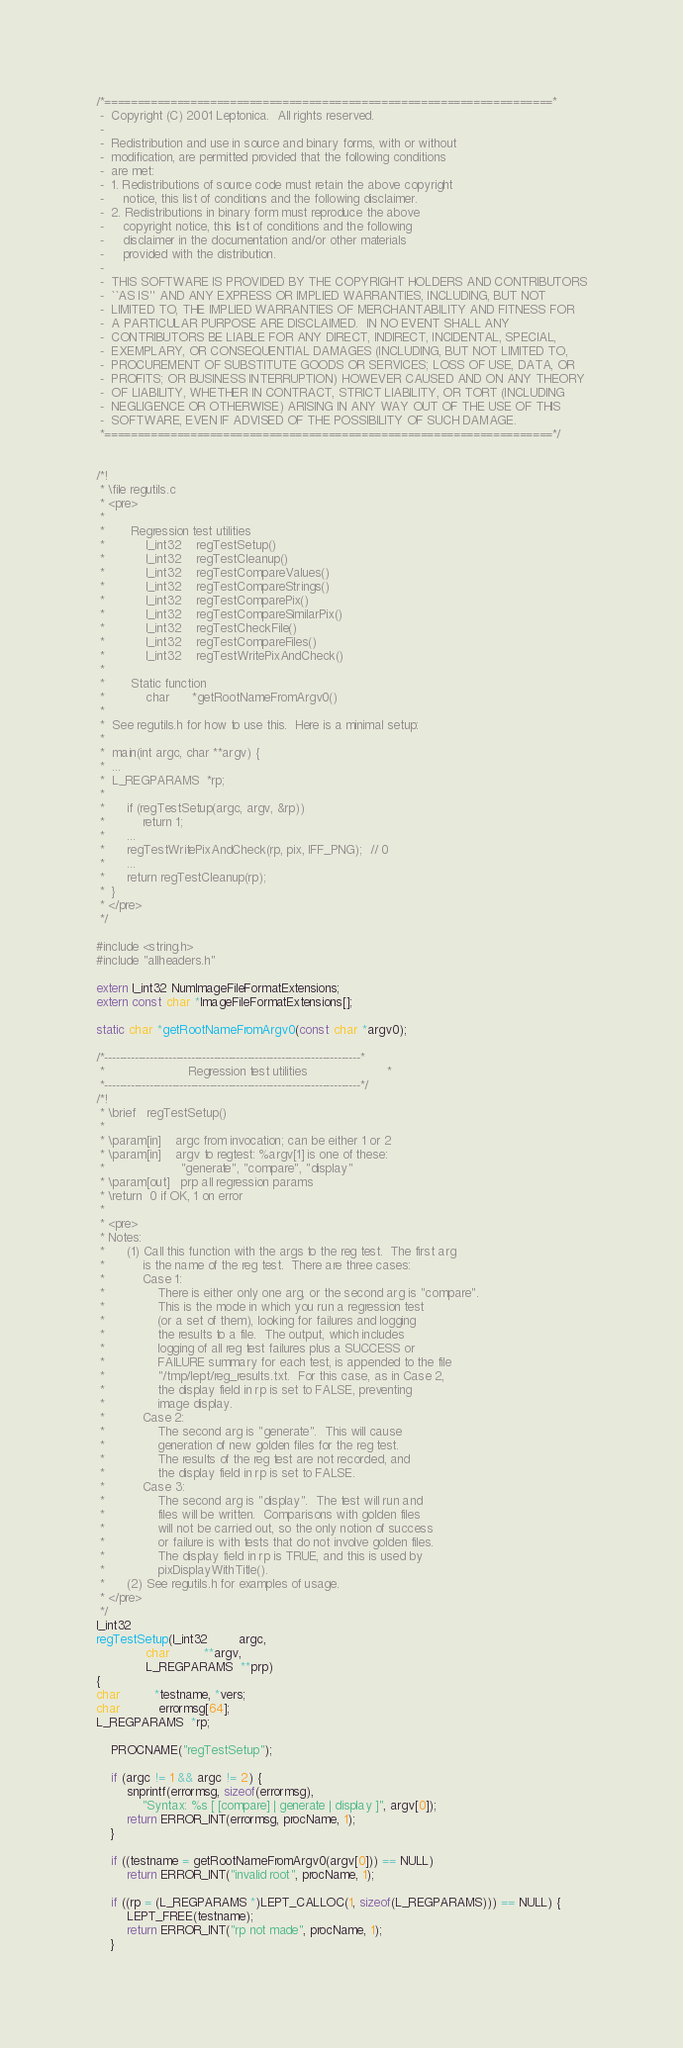<code> <loc_0><loc_0><loc_500><loc_500><_C_>/*====================================================================*
 -  Copyright (C) 2001 Leptonica.  All rights reserved.
 -
 -  Redistribution and use in source and binary forms, with or without
 -  modification, are permitted provided that the following conditions
 -  are met:
 -  1. Redistributions of source code must retain the above copyright
 -     notice, this list of conditions and the following disclaimer.
 -  2. Redistributions in binary form must reproduce the above
 -     copyright notice, this list of conditions and the following
 -     disclaimer in the documentation and/or other materials
 -     provided with the distribution.
 -
 -  THIS SOFTWARE IS PROVIDED BY THE COPYRIGHT HOLDERS AND CONTRIBUTORS
 -  ``AS IS'' AND ANY EXPRESS OR IMPLIED WARRANTIES, INCLUDING, BUT NOT
 -  LIMITED TO, THE IMPLIED WARRANTIES OF MERCHANTABILITY AND FITNESS FOR
 -  A PARTICULAR PURPOSE ARE DISCLAIMED.  IN NO EVENT SHALL ANY
 -  CONTRIBUTORS BE LIABLE FOR ANY DIRECT, INDIRECT, INCIDENTAL, SPECIAL,
 -  EXEMPLARY, OR CONSEQUENTIAL DAMAGES (INCLUDING, BUT NOT LIMITED TO,
 -  PROCUREMENT OF SUBSTITUTE GOODS OR SERVICES; LOSS OF USE, DATA, OR
 -  PROFITS; OR BUSINESS INTERRUPTION) HOWEVER CAUSED AND ON ANY THEORY
 -  OF LIABILITY, WHETHER IN CONTRACT, STRICT LIABILITY, OR TORT (INCLUDING
 -  NEGLIGENCE OR OTHERWISE) ARISING IN ANY WAY OUT OF THE USE OF THIS
 -  SOFTWARE, EVEN IF ADVISED OF THE POSSIBILITY OF SUCH DAMAGE.
 *====================================================================*/


/*!
 * \file regutils.c
 * <pre>
 *
 *       Regression test utilities
 *           l_int32    regTestSetup()
 *           l_int32    regTestCleanup()
 *           l_int32    regTestCompareValues()
 *           l_int32    regTestCompareStrings()
 *           l_int32    regTestComparePix()
 *           l_int32    regTestCompareSimilarPix()
 *           l_int32    regTestCheckFile()
 *           l_int32    regTestCompareFiles()
 *           l_int32    regTestWritePixAndCheck()
 *
 *       Static function
 *           char      *getRootNameFromArgv0()
 *
 *  See regutils.h for how to use this.  Here is a minimal setup:
 *
 *  main(int argc, char **argv) {
 *  ...
 *  L_REGPARAMS  *rp;
 *
 *      if (regTestSetup(argc, argv, &rp))
 *          return 1;
 *      ...
 *      regTestWritePixAndCheck(rp, pix, IFF_PNG);  // 0
 *      ...
 *      return regTestCleanup(rp);
 *  }
 * </pre>
 */

#include <string.h>
#include "allheaders.h"

extern l_int32 NumImageFileFormatExtensions;
extern const char *ImageFileFormatExtensions[];

static char *getRootNameFromArgv0(const char *argv0);

/*--------------------------------------------------------------------*
 *                      Regression test utilities                     *
 *--------------------------------------------------------------------*/
/*!
 * \brief   regTestSetup()
 *
 * \param[in]    argc from invocation; can be either 1 or 2
 * \param[in]    argv to regtest: %argv[1] is one of these:
 *                    "generate", "compare", "display"
 * \param[out]   prp all regression params
 * \return  0 if OK, 1 on error
 *
 * <pre>
 * Notes:
 *      (1) Call this function with the args to the reg test.  The first arg
 *          is the name of the reg test.  There are three cases:
 *          Case 1:
 *              There is either only one arg, or the second arg is "compare".
 *              This is the mode in which you run a regression test
 *              (or a set of them), looking for failures and logging
 *              the results to a file.  The output, which includes
 *              logging of all reg test failures plus a SUCCESS or
 *              FAILURE summary for each test, is appended to the file
 *              "/tmp/lept/reg_results.txt.  For this case, as in Case 2,
 *              the display field in rp is set to FALSE, preventing
 *              image display.
 *          Case 2:
 *              The second arg is "generate".  This will cause
 *              generation of new golden files for the reg test.
 *              The results of the reg test are not recorded, and
 *              the display field in rp is set to FALSE.
 *          Case 3:
 *              The second arg is "display".  The test will run and
 *              files will be written.  Comparisons with golden files
 *              will not be carried out, so the only notion of success
 *              or failure is with tests that do not involve golden files.
 *              The display field in rp is TRUE, and this is used by
 *              pixDisplayWithTitle().
 *      (2) See regutils.h for examples of usage.
 * </pre>
 */
l_int32
regTestSetup(l_int32        argc,
             char         **argv,
             L_REGPARAMS  **prp)
{
char         *testname, *vers;
char          errormsg[64];
L_REGPARAMS  *rp;

    PROCNAME("regTestSetup");

    if (argc != 1 && argc != 2) {
        snprintf(errormsg, sizeof(errormsg),
            "Syntax: %s [ [compare] | generate | display ]", argv[0]);
        return ERROR_INT(errormsg, procName, 1);
    }

    if ((testname = getRootNameFromArgv0(argv[0])) == NULL)
        return ERROR_INT("invalid root", procName, 1);

    if ((rp = (L_REGPARAMS *)LEPT_CALLOC(1, sizeof(L_REGPARAMS))) == NULL) {
        LEPT_FREE(testname);
        return ERROR_INT("rp not made", procName, 1);
    }</code> 